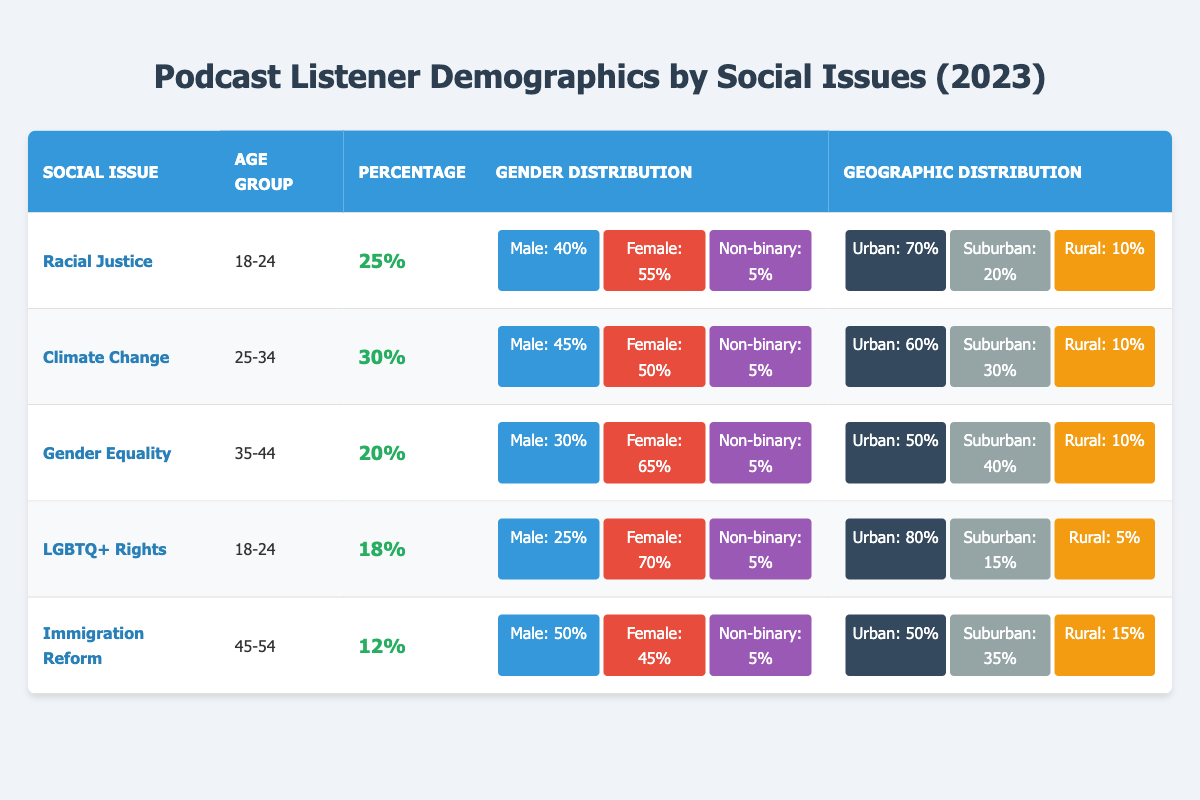What is the percentage of listeners who care about Racial Justice? The table shows that for the social issue of Racial Justice, the percentage of listeners in the age group of 18-24 is 25%. This value is directly shown in the table.
Answer: 25% Which age group has the highest percentage of listeners interested in Climate Change? Based on the table, the age group of 25-34 has an interest in Climate Change, and it shows a percentage of 30%. This is the only entry for this social issue, so it inherently has the highest percentage.
Answer: 30% Are there more female listeners interested in Gender Equality compared to male listeners? For Gender Equality, the table indicates that there are 65% female listeners and 30% male listeners. Since 65% (female) is greater than 30% (male), the answer is yes.
Answer: Yes What is the male percentage of listeners for LGBTQ+ Rights? Looking at the table, the male percentage for LGBTQ+ Rights in the age group of 18-24 is noted as 25%. This is a straightforward retrieval from the table.
Answer: 25% Which social issue has the lowest percentage of listeners and what is that percentage? The table indicates that Immigration Reform has the lowest percentage at 12%. By comparing all the social issues listed, this value stands out as the lowest.
Answer: 12% How do the percentages of listeners for Climate Change and Gender Equality compare? Climate Change has a percentage of 30%, and Gender Equality shows a percentage of 20%. By subtracting, we see that Climate Change is more popular by 10%.
Answer: Climate Change is 10% higher What is the total percentage of listeners who are non-binary across all social issues? To find the total percentage of non-binary listeners, we add the non-binary percentages from each social issue: 5% (Racial Justice) + 5% (Climate Change) + 5% (Gender Equality) + 5% (LGBTQ+ Rights) + 5% (Immigration Reform) = 25%.
Answer: 25% Which age group has the least engagement with the social issues listed? By considering the percentages, Immigration Reform in the age group 45-54 has the lowest at 12%. Thus, this age group shows the least engagement compared to others.
Answer: 45-54 Are the majority of listeners for Racial Justice from urban areas? The table states that 70% of listeners for Racial Justice are from urban areas. Since this is a majority (over 50%), the answer is yes.
Answer: Yes In which social issue is there equal distribution between male and female listeners? The table does not show any percentage where male and female listeners are equal, with the closest being Immigration Reform (50% male, 45% female). Hence, there is no exact equal distribution.
Answer: No 